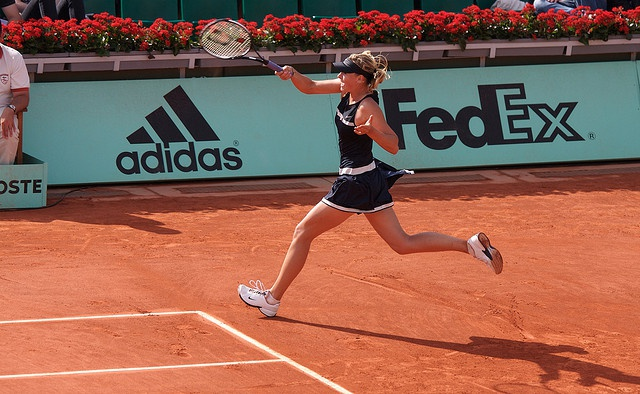Describe the objects in this image and their specific colors. I can see people in black and brown tones, people in black, darkgray, brown, maroon, and gray tones, tennis racket in black, gray, and darkgray tones, people in black, navy, gray, and darkgray tones, and people in gray, black, brown, and maroon tones in this image. 